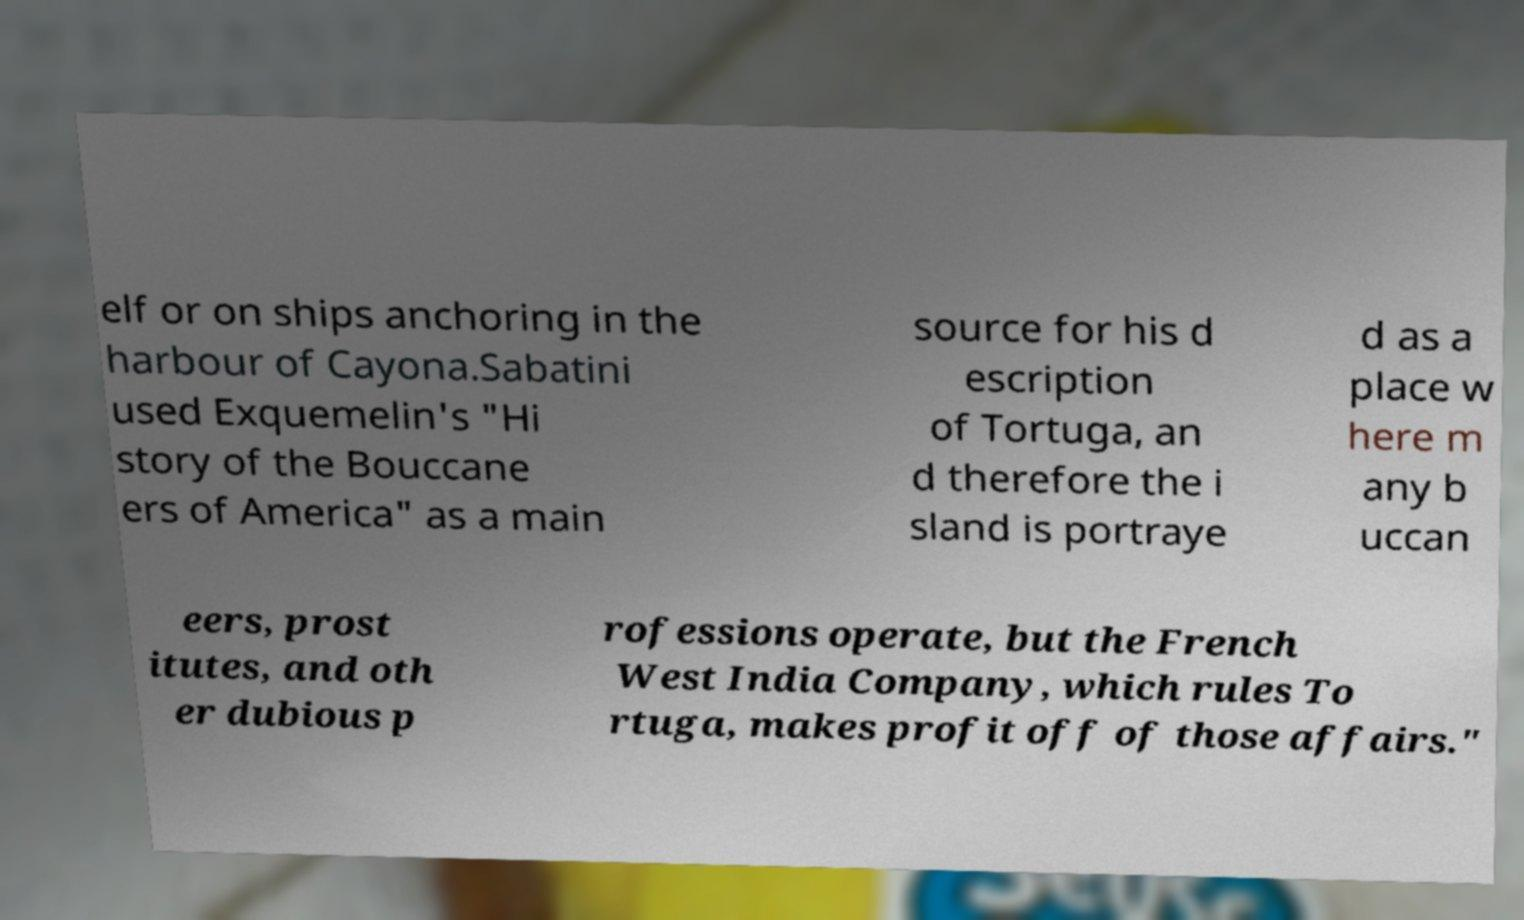Could you extract and type out the text from this image? elf or on ships anchoring in the harbour of Cayona.Sabatini used Exquemelin's "Hi story of the Bouccane ers of America" as a main source for his d escription of Tortuga, an d therefore the i sland is portraye d as a place w here m any b uccan eers, prost itutes, and oth er dubious p rofessions operate, but the French West India Company, which rules To rtuga, makes profit off of those affairs." 